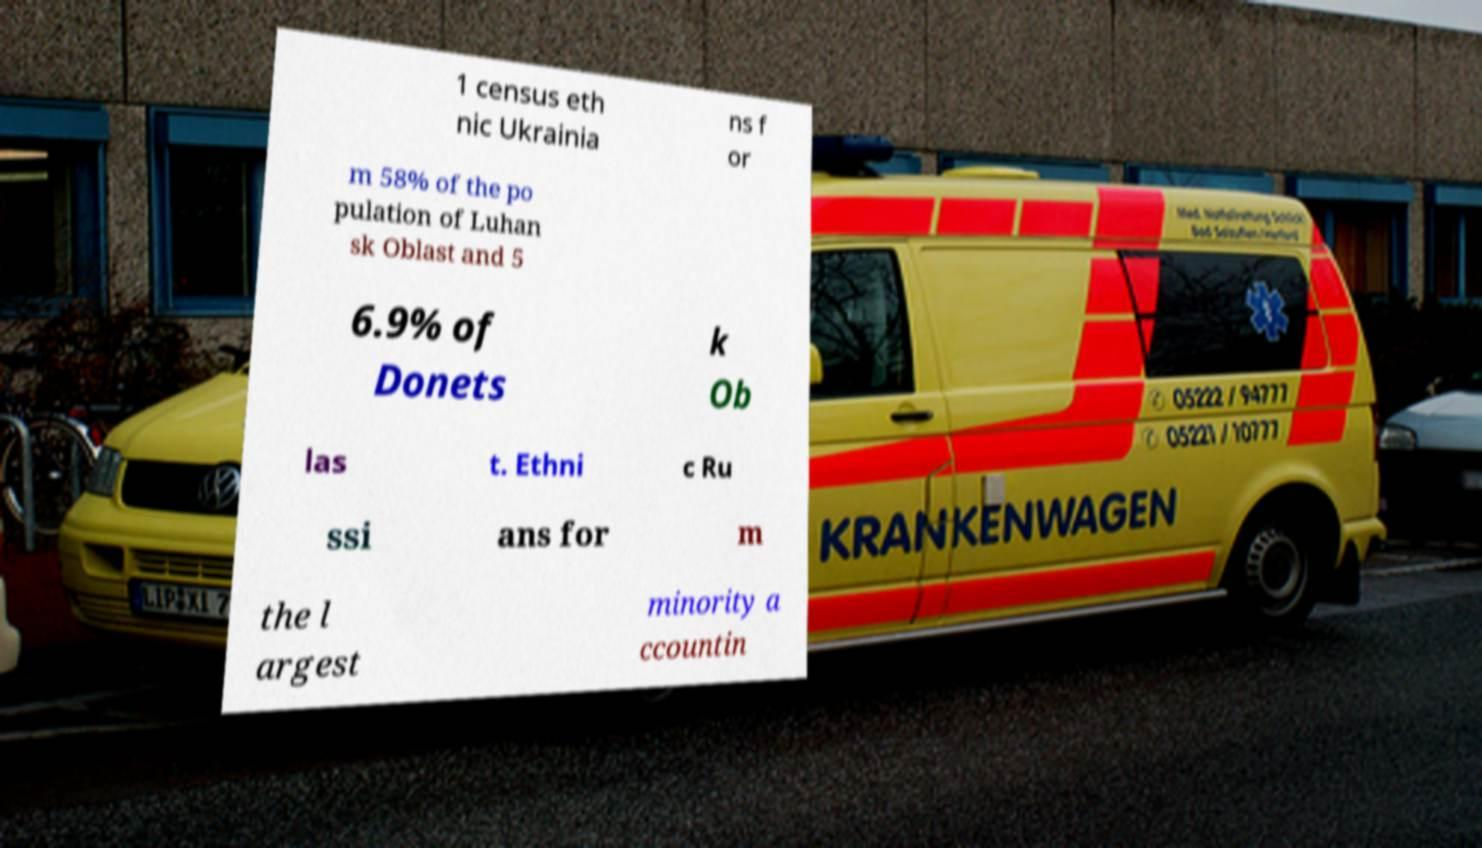For documentation purposes, I need the text within this image transcribed. Could you provide that? 1 census eth nic Ukrainia ns f or m 58% of the po pulation of Luhan sk Oblast and 5 6.9% of Donets k Ob las t. Ethni c Ru ssi ans for m the l argest minority a ccountin 